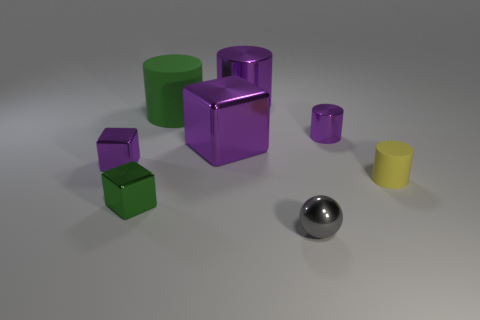Is the number of green cylinders that are to the right of the tiny gray shiny sphere greater than the number of small cylinders in front of the green shiny cube?
Your answer should be compact. No. What size is the green block that is the same material as the small sphere?
Your answer should be very brief. Small. There is a metal object that is behind the rubber cylinder that is behind the small purple object that is in front of the large metallic cube; what size is it?
Offer a terse response. Large. What is the color of the big thing that is in front of the large green cylinder?
Your answer should be compact. Purple. Is the number of yellow matte cylinders that are left of the green matte cylinder greater than the number of large purple shiny cylinders?
Your response must be concise. No. Is the shape of the tiny purple thing right of the green block the same as  the small yellow thing?
Offer a very short reply. Yes. How many yellow objects are tiny things or tiny matte objects?
Make the answer very short. 1. Is the number of small balls greater than the number of tiny things?
Keep it short and to the point. No. What is the color of the ball that is the same size as the green cube?
Provide a short and direct response. Gray. What number of cylinders are either tiny gray shiny objects or yellow things?
Provide a short and direct response. 1. 